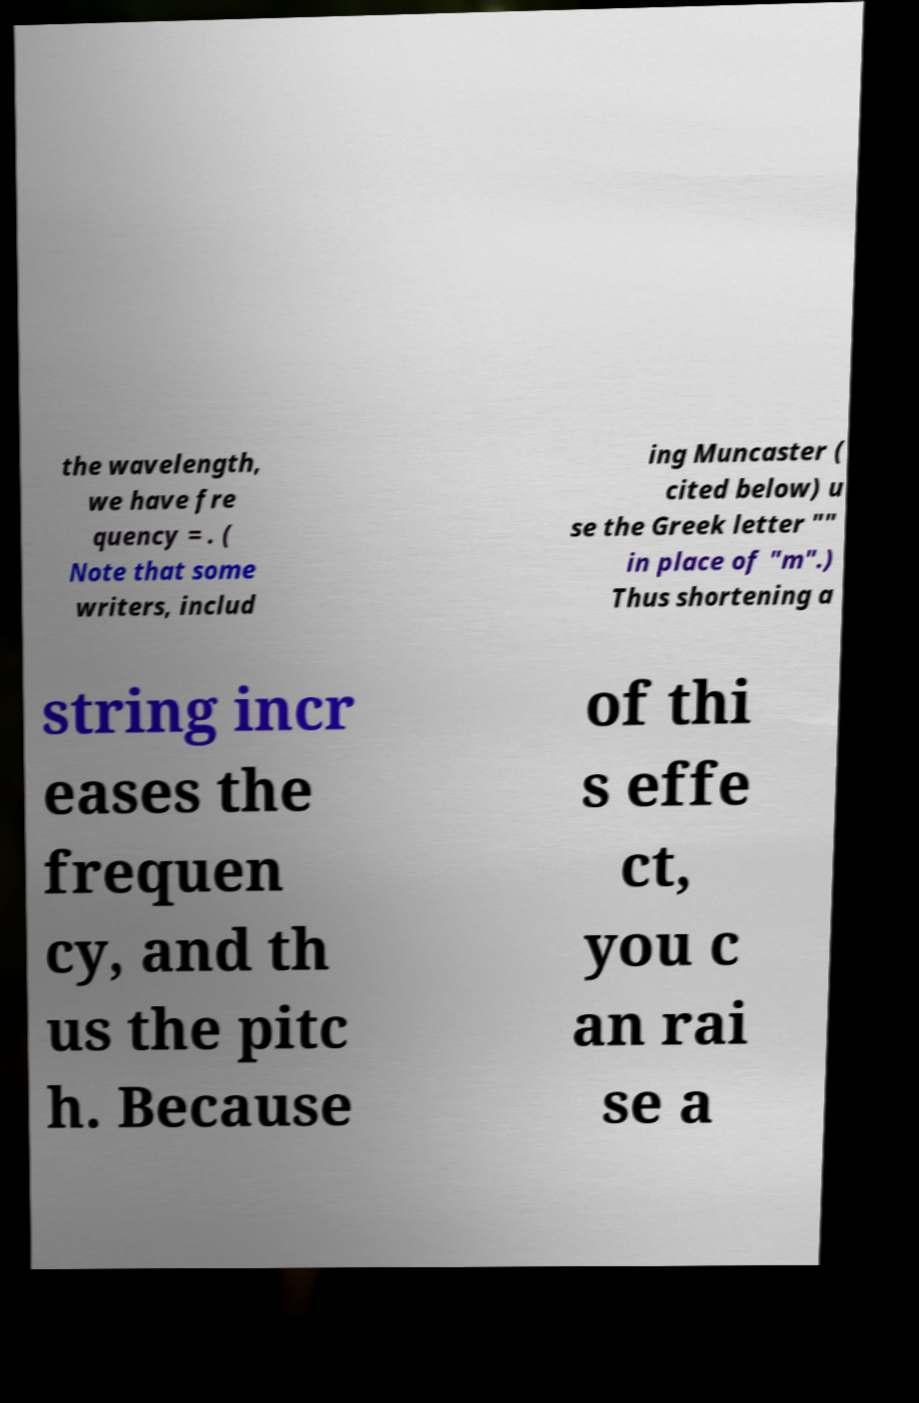Could you assist in decoding the text presented in this image and type it out clearly? the wavelength, we have fre quency = . ( Note that some writers, includ ing Muncaster ( cited below) u se the Greek letter "" in place of "m".) Thus shortening a string incr eases the frequen cy, and th us the pitc h. Because of thi s effe ct, you c an rai se a 